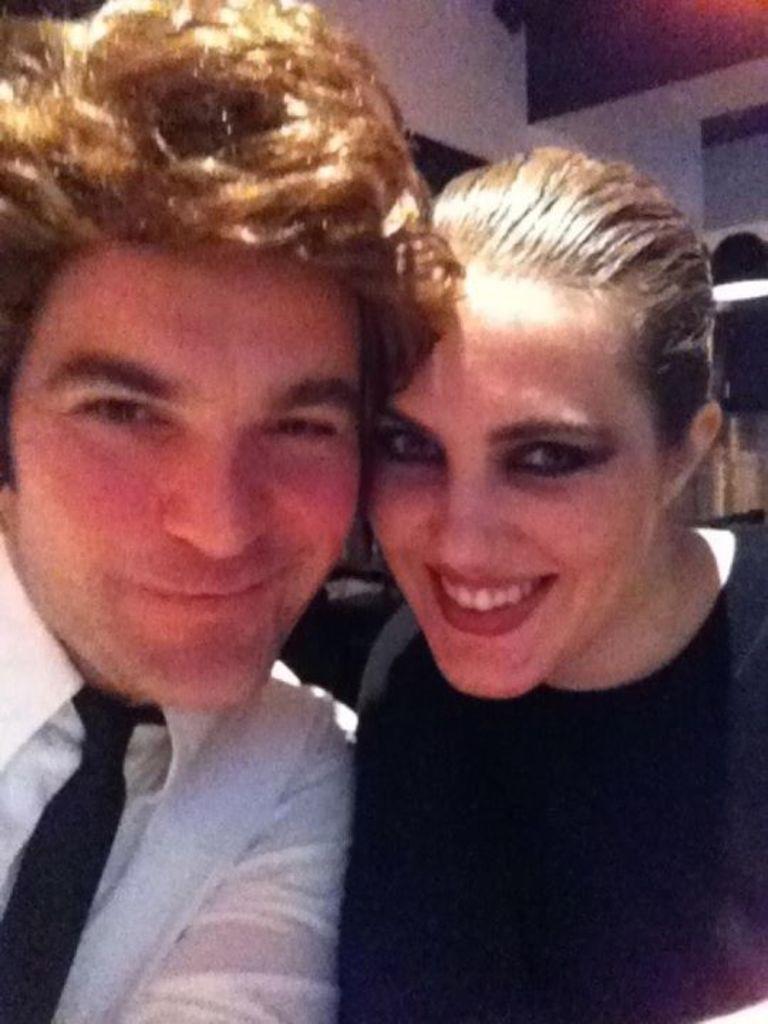Describe this image in one or two sentences. In this image we can see a man and a woman. In the background we can see the wall, light and objects. 